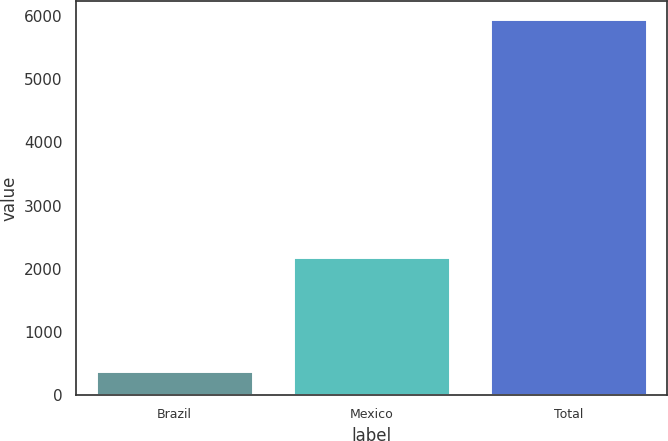Convert chart. <chart><loc_0><loc_0><loc_500><loc_500><bar_chart><fcel>Brazil<fcel>Mexico<fcel>Total<nl><fcel>380<fcel>2186<fcel>5945<nl></chart> 